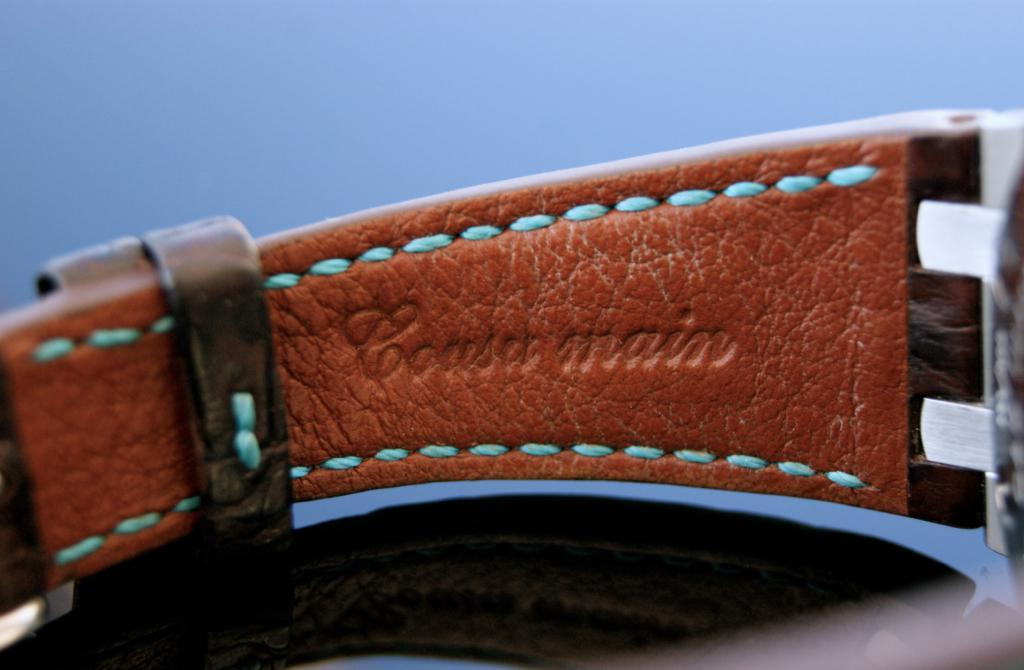<image>
Summarize the visual content of the image. A brown watch strap is imprinted with the words "Coasa main". 